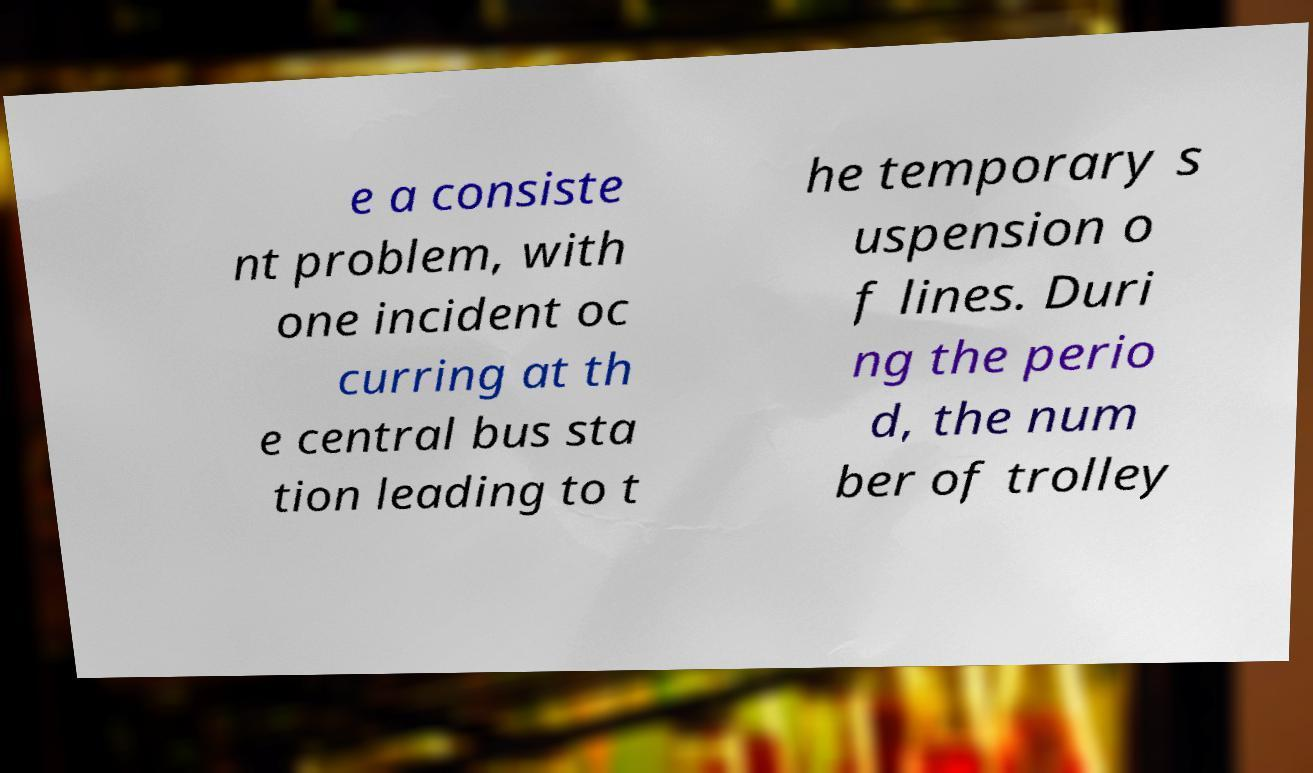I need the written content from this picture converted into text. Can you do that? e a consiste nt problem, with one incident oc curring at th e central bus sta tion leading to t he temporary s uspension o f lines. Duri ng the perio d, the num ber of trolley 